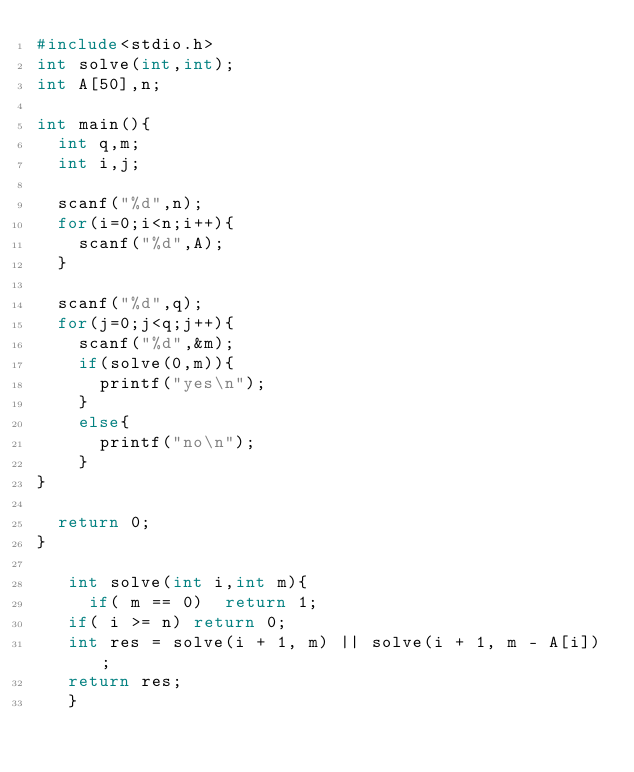Convert code to text. <code><loc_0><loc_0><loc_500><loc_500><_C_>#include<stdio.h>
int solve(int,int);
int A[50],n;

int main(){
  int q,m;
  int i,j;

  scanf("%d",n);
  for(i=0;i<n;i++){
    scanf("%d",A);
  }

  scanf("%d",q);
  for(j=0;j<q;j++){
    scanf("%d",&m);
    if(solve(0,m)){
      printf("yes\n");
    }
    else{
      printf("no\n");
    }
}

  return 0;
}

   int solve(int i,int m){
     if( m == 0)  return 1;
   if( i >= n) return 0;
   int res = solve(i + 1, m) || solve(i + 1, m - A[i]);
   return res;
   }

</code> 